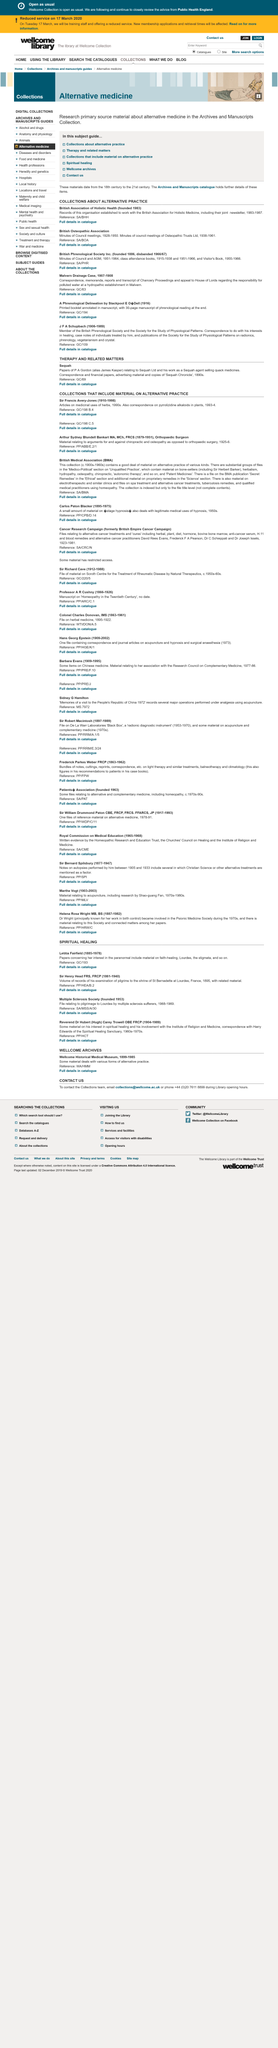List a handful of essential elements in this visual. The British Association of Holistic Health was founded in 1983. The British Association of Holistic Health's joint newsletter was in operation from 1983 to 1987. The minutes of the British Osteopathic Association Council meetings were recorded from 1928 to 1950. 